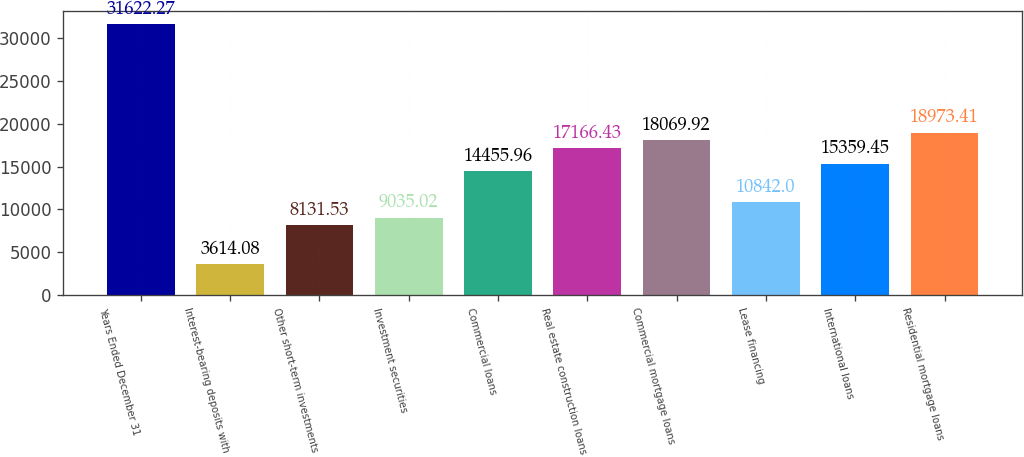<chart> <loc_0><loc_0><loc_500><loc_500><bar_chart><fcel>Years Ended December 31<fcel>Interest-bearing deposits with<fcel>Other short-term investments<fcel>Investment securities<fcel>Commercial loans<fcel>Real estate construction loans<fcel>Commercial mortgage loans<fcel>Lease financing<fcel>International loans<fcel>Residential mortgage loans<nl><fcel>31622.3<fcel>3614.08<fcel>8131.53<fcel>9035.02<fcel>14456<fcel>17166.4<fcel>18069.9<fcel>10842<fcel>15359.5<fcel>18973.4<nl></chart> 